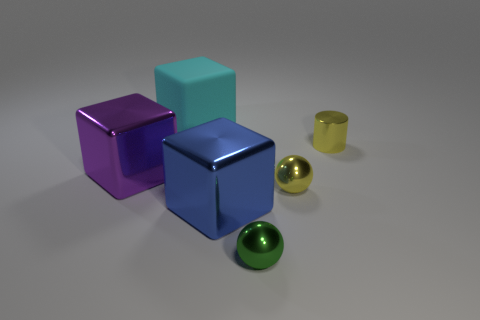Add 1 large matte objects. How many objects exist? 7 Subtract all cylinders. How many objects are left? 5 Add 6 big cyan objects. How many big cyan objects exist? 7 Subtract 0 gray cylinders. How many objects are left? 6 Subtract all small yellow cylinders. Subtract all purple metal cubes. How many objects are left? 4 Add 3 yellow metallic balls. How many yellow metallic balls are left? 4 